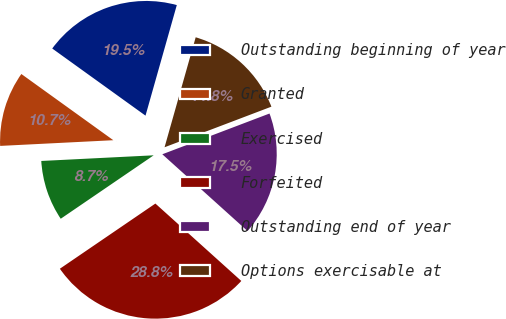<chart> <loc_0><loc_0><loc_500><loc_500><pie_chart><fcel>Outstanding beginning of year<fcel>Granted<fcel>Exercised<fcel>Forfeited<fcel>Outstanding end of year<fcel>Options exercisable at<nl><fcel>19.46%<fcel>10.73%<fcel>8.73%<fcel>28.8%<fcel>17.45%<fcel>14.83%<nl></chart> 